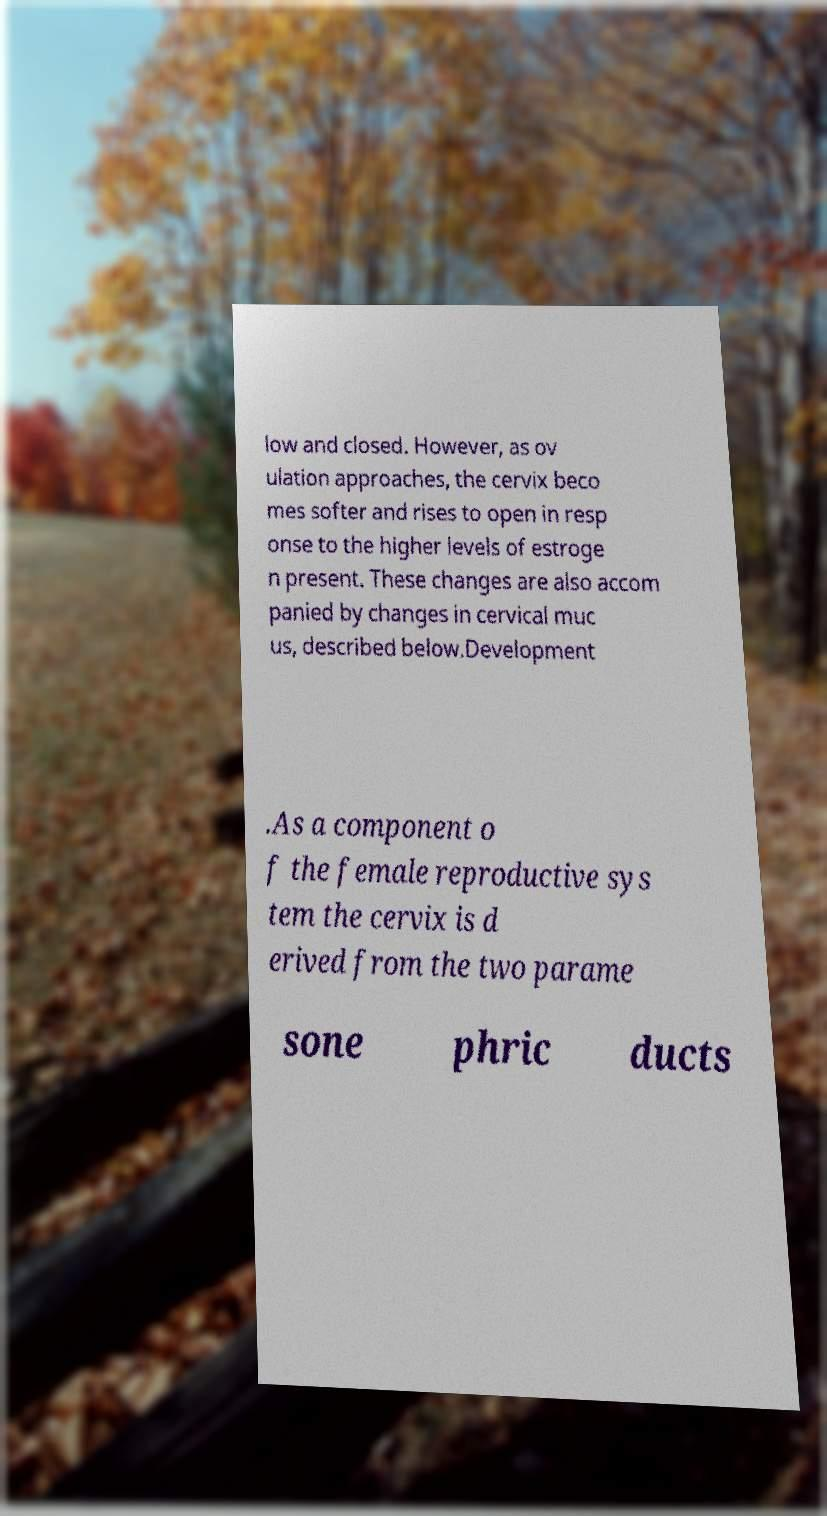Please identify and transcribe the text found in this image. low and closed. However, as ov ulation approaches, the cervix beco mes softer and rises to open in resp onse to the higher levels of estroge n present. These changes are also accom panied by changes in cervical muc us, described below.Development .As a component o f the female reproductive sys tem the cervix is d erived from the two parame sone phric ducts 